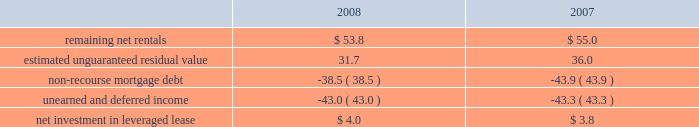Kimco realty corporation and subsidiaries notes to consolidated financial statements , continued investment in retail store leases the company has interests in various retail store leases relating to the anchor store premises in neighborhood and community shopping centers .
These premises have been sublet to retailers who lease the stores pursuant to net lease agreements .
Income from the investment in these retail store leases during the years ended december 31 , 2008 , 2007 and 2006 , was approximately $ 2.7 million , $ 1.2 million and $ 1.3 million , respectively .
These amounts represent sublease revenues during the years ended december 31 , 2008 , 2007 and 2006 , of approximately $ 7.1 million , $ 7.7 million and $ 8.2 million , respectively , less related expenses of $ 4.4 million , $ 5.1 million and $ 5.7 million , respectively , and an amount which , in management 2019s estimate , reasonably provides for the recovery of the investment over a period representing the expected remaining term of the retail store leases .
The company 2019s future minimum revenues under the terms of all non-cancelable tenant subleases and future minimum obligations through the remaining terms of its retail store leases , assuming no new or renegotiated leases are executed for such premises , for future years are as follows ( in millions ) : 2009 , $ 5.6 and $ 3.8 ; 2010 , $ 5.4 and $ 3.7 ; 2011 , $ 4.5 and $ 3.1 ; 2012 , $ 2.3 and $ 2.1 ; 2013 , $ 1.0 and $ 1.3 and thereafter , $ 1.4 and $ 0.5 , respectively .
Leveraged lease during june 2002 , the company acquired a 90% ( 90 % ) equity participation interest in an existing leveraged lease of 30 properties .
The properties are leased under a long-term bond-type net lease whose primary term expires in 2016 , with the lessee having certain renewal option rights .
The company 2019s cash equity investment was approximately $ 4.0 million .
This equity investment is reported as a net investment in leveraged lease in accordance with sfas no .
13 , accounting for leases ( as amended ) .
From 2002 to 2007 , 18 of these properties were sold , whereby the proceeds from the sales were used to pay down the mortgage debt by approximately $ 31.2 million .
As of december 31 , 2008 , the remaining 12 properties were encumbered by third-party non-recourse debt of approximately $ 42.8 million that is scheduled to fully amortize during the primary term of the lease from a portion of the periodic net rents receivable under the net lease .
As an equity participant in the leveraged lease , the company has no recourse obligation for principal or interest payments on the debt , which is collateralized by a first mortgage lien on the properties and collateral assignment of the lease .
Accordingly , this obligation has been offset against the related net rental receivable under the lease .
At december 31 , 2008 and 2007 , the company 2019s net investment in the leveraged lease consisted of the following ( in millions ) : .
Mortgages and other financing receivables : the company has various mortgages and other financing receivables which consist of loans acquired and loans originated by the company .
For a complete listing of the company 2019s mortgages and other financing receivables at december 31 , 2008 , see financial statement schedule iv included on page 141 of this annual report on form 10-k .
Reconciliation of mortgage loans and other financing receivables on real estate: .
What is the growth rate in sublease revenues from 2007 to 2008? 
Computations: ((7.1 - 7.7) / 7.7)
Answer: -0.07792. 